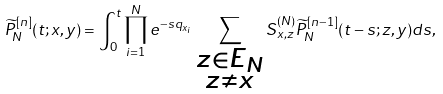Convert formula to latex. <formula><loc_0><loc_0><loc_500><loc_500>\widetilde { P } _ { N } ^ { [ n ] } ( t ; x , y ) = \int _ { 0 } ^ { t } { \prod _ { i = 1 } ^ { N } { e ^ { - s q _ { x _ { i } } } } \sum _ { \substack { z \in E _ { N } \\ z \neq x } } { S ^ { ( N ) } _ { x , z } \widetilde { P } _ { N } ^ { [ n - 1 ] } ( t - s ; z , y ) } d s } ,</formula> 